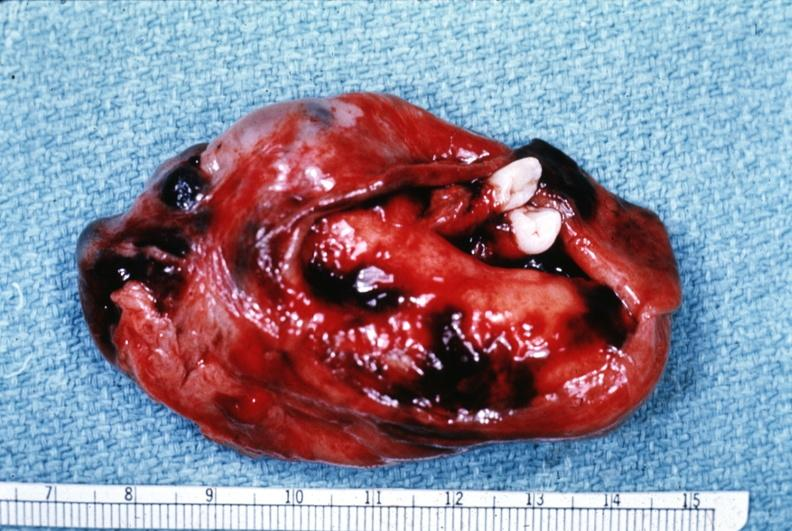what is present?
Answer the question using a single word or phrase. Benign cystic teratoma 